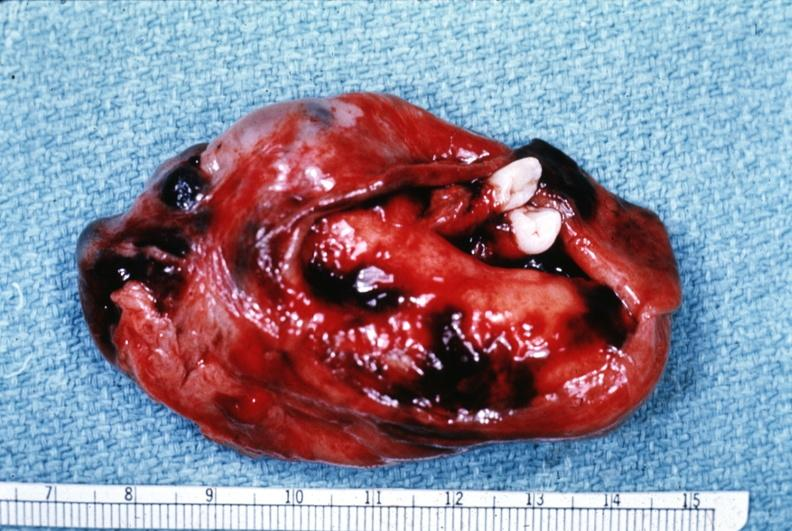what is present?
Answer the question using a single word or phrase. Benign cystic teratoma 